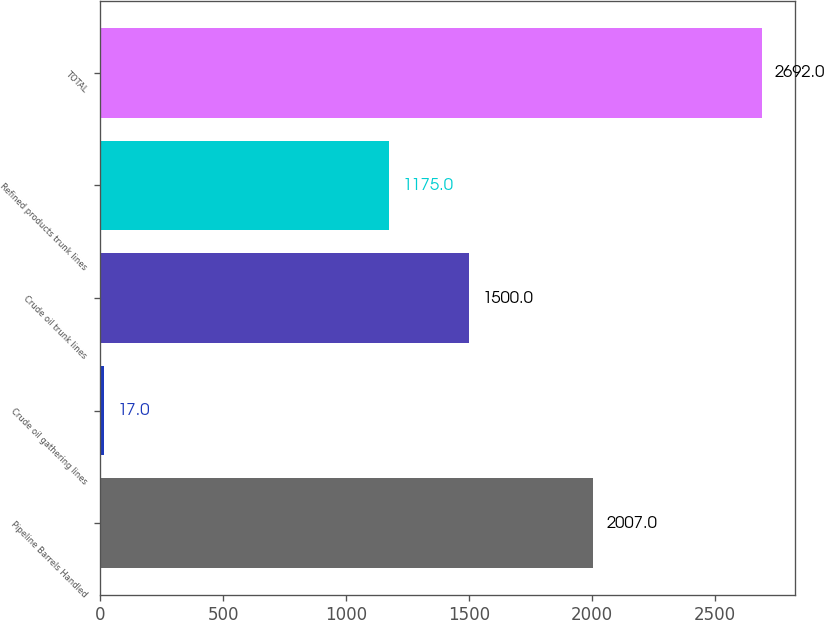Convert chart to OTSL. <chart><loc_0><loc_0><loc_500><loc_500><bar_chart><fcel>Pipeline Barrels Handled<fcel>Crude oil gathering lines<fcel>Crude oil trunk lines<fcel>Refined products trunk lines<fcel>TOTAL<nl><fcel>2007<fcel>17<fcel>1500<fcel>1175<fcel>2692<nl></chart> 